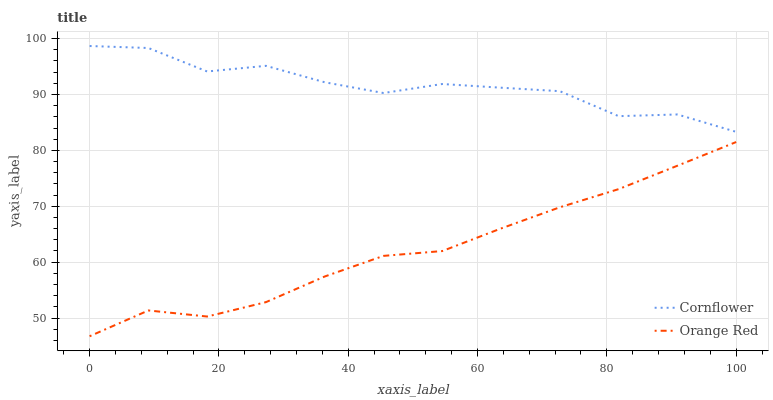Does Orange Red have the minimum area under the curve?
Answer yes or no. Yes. Does Cornflower have the maximum area under the curve?
Answer yes or no. Yes. Does Orange Red have the maximum area under the curve?
Answer yes or no. No. Is Orange Red the smoothest?
Answer yes or no. Yes. Is Cornflower the roughest?
Answer yes or no. Yes. Is Orange Red the roughest?
Answer yes or no. No. Does Orange Red have the lowest value?
Answer yes or no. Yes. Does Cornflower have the highest value?
Answer yes or no. Yes. Does Orange Red have the highest value?
Answer yes or no. No. Is Orange Red less than Cornflower?
Answer yes or no. Yes. Is Cornflower greater than Orange Red?
Answer yes or no. Yes. Does Orange Red intersect Cornflower?
Answer yes or no. No. 